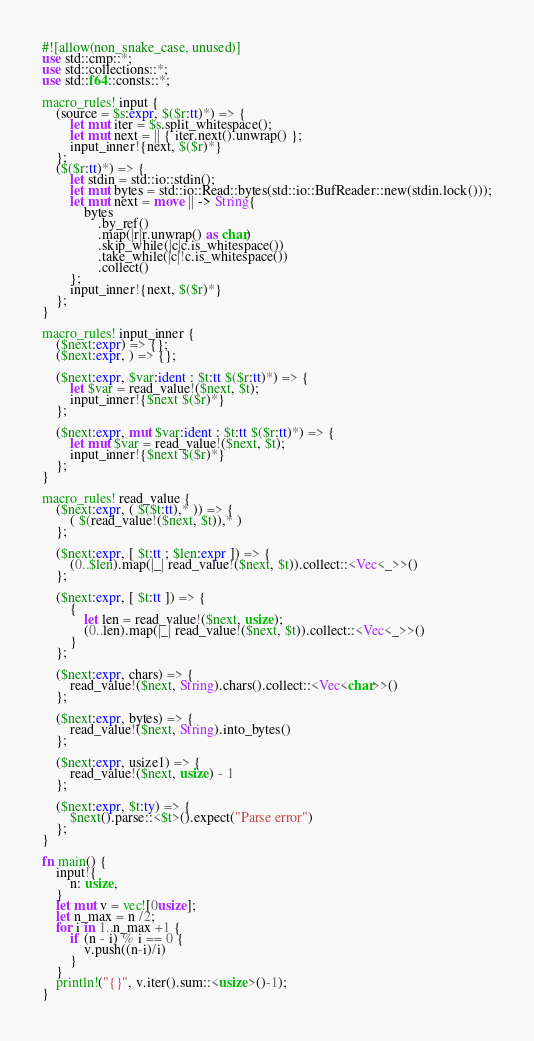<code> <loc_0><loc_0><loc_500><loc_500><_Rust_>#![allow(non_snake_case, unused)]
use std::cmp::*;
use std::collections::*;
use std::f64::consts::*;

macro_rules! input {
    (source = $s:expr, $($r:tt)*) => {
        let mut iter = $s.split_whitespace();
        let mut next = || { iter.next().unwrap() };
        input_inner!{next, $($r)*}
    };
    ($($r:tt)*) => {
        let stdin = std::io::stdin();
        let mut bytes = std::io::Read::bytes(std::io::BufReader::new(stdin.lock()));
        let mut next = move || -> String{
            bytes
                .by_ref()
                .map(|r|r.unwrap() as char)
                .skip_while(|c|c.is_whitespace())
                .take_while(|c|!c.is_whitespace())
                .collect()
        };
        input_inner!{next, $($r)*}
    };
}

macro_rules! input_inner {
    ($next:expr) => {};
    ($next:expr, ) => {};

    ($next:expr, $var:ident : $t:tt $($r:tt)*) => {
        let $var = read_value!($next, $t);
        input_inner!{$next $($r)*}
    };

    ($next:expr, mut $var:ident : $t:tt $($r:tt)*) => {
        let mut $var = read_value!($next, $t);
        input_inner!{$next $($r)*}
    };
}

macro_rules! read_value {
    ($next:expr, ( $($t:tt),* )) => {
        ( $(read_value!($next, $t)),* )
    };

    ($next:expr, [ $t:tt ; $len:expr ]) => {
        (0..$len).map(|_| read_value!($next, $t)).collect::<Vec<_>>()
    };

    ($next:expr, [ $t:tt ]) => {
        {
            let len = read_value!($next, usize);
            (0..len).map(|_| read_value!($next, $t)).collect::<Vec<_>>()
        }
    };

    ($next:expr, chars) => {
        read_value!($next, String).chars().collect::<Vec<char>>()
    };

    ($next:expr, bytes) => {
        read_value!($next, String).into_bytes()
    };

    ($next:expr, usize1) => {
        read_value!($next, usize) - 1
    };

    ($next:expr, $t:ty) => {
        $next().parse::<$t>().expect("Parse error")
    };
}

fn main() {
    input!{
        n: usize,
    }
    let mut v = vec![0usize];
    let n_max = n /2;
    for i in 1..n_max +1 {
        if (n - i) % i == 0 {
            v.push((n-i)/i)
        }
    }
    println!("{}", v.iter().sum::<usize>()-1);
}
</code> 